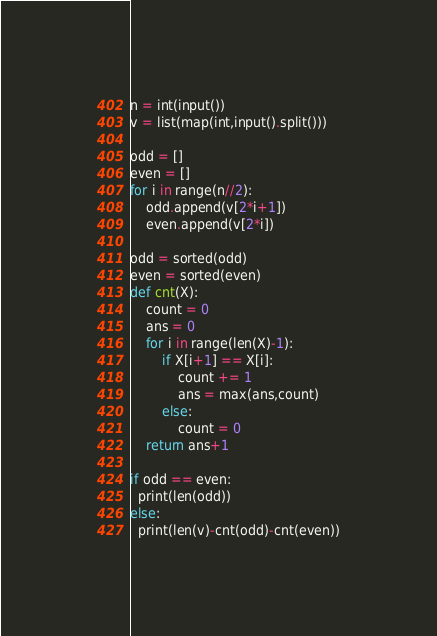<code> <loc_0><loc_0><loc_500><loc_500><_Python_>n = int(input())
v = list(map(int,input().split()))

odd = []
even = []
for i in range(n//2):
	odd.append(v[2*i+1])
	even.append(v[2*i])

odd = sorted(odd)
even = sorted(even)
def cnt(X):
	count = 0
	ans = 0
	for i in range(len(X)-1):
		if X[i+1] == X[i]:
			count += 1
			ans = max(ans,count)
		else:
			count = 0
	return ans+1
            
if odd == even:
  print(len(odd))
else:
  print(len(v)-cnt(odd)-cnt(even))</code> 